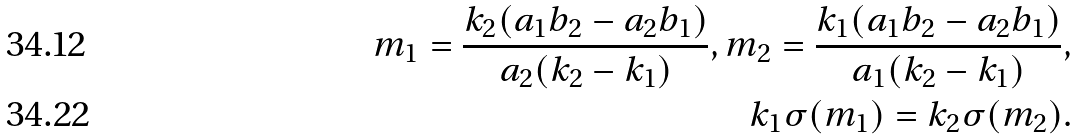Convert formula to latex. <formula><loc_0><loc_0><loc_500><loc_500>m _ { 1 } = \frac { k _ { 2 } ( a _ { 1 } b _ { 2 } - a _ { 2 } b _ { 1 } ) } { a _ { 2 } ( k _ { 2 } - k _ { 1 } ) } , m _ { 2 } = \frac { k _ { 1 } ( a _ { 1 } b _ { 2 } - a _ { 2 } b _ { 1 } ) } { a _ { 1 } ( k _ { 2 } - k _ { 1 } ) } , \\ k _ { 1 } \sigma ( m _ { 1 } ) = k _ { 2 } \sigma ( m _ { 2 } ) .</formula> 